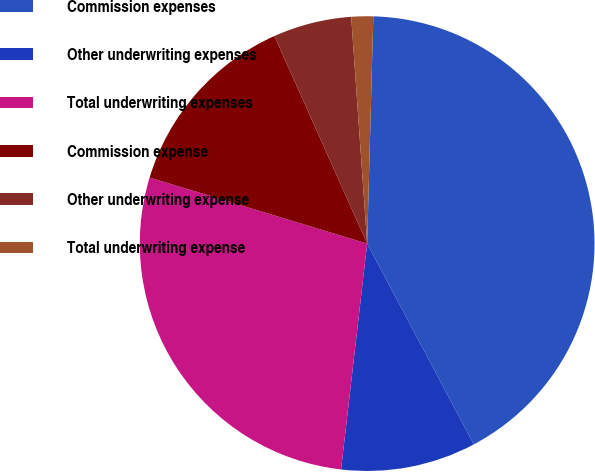Convert chart to OTSL. <chart><loc_0><loc_0><loc_500><loc_500><pie_chart><fcel>Commission expenses<fcel>Other underwriting expenses<fcel>Total underwriting expenses<fcel>Commission expense<fcel>Other underwriting expense<fcel>Total underwriting expense<nl><fcel>41.8%<fcel>9.6%<fcel>27.86%<fcel>13.62%<fcel>5.57%<fcel>1.55%<nl></chart> 